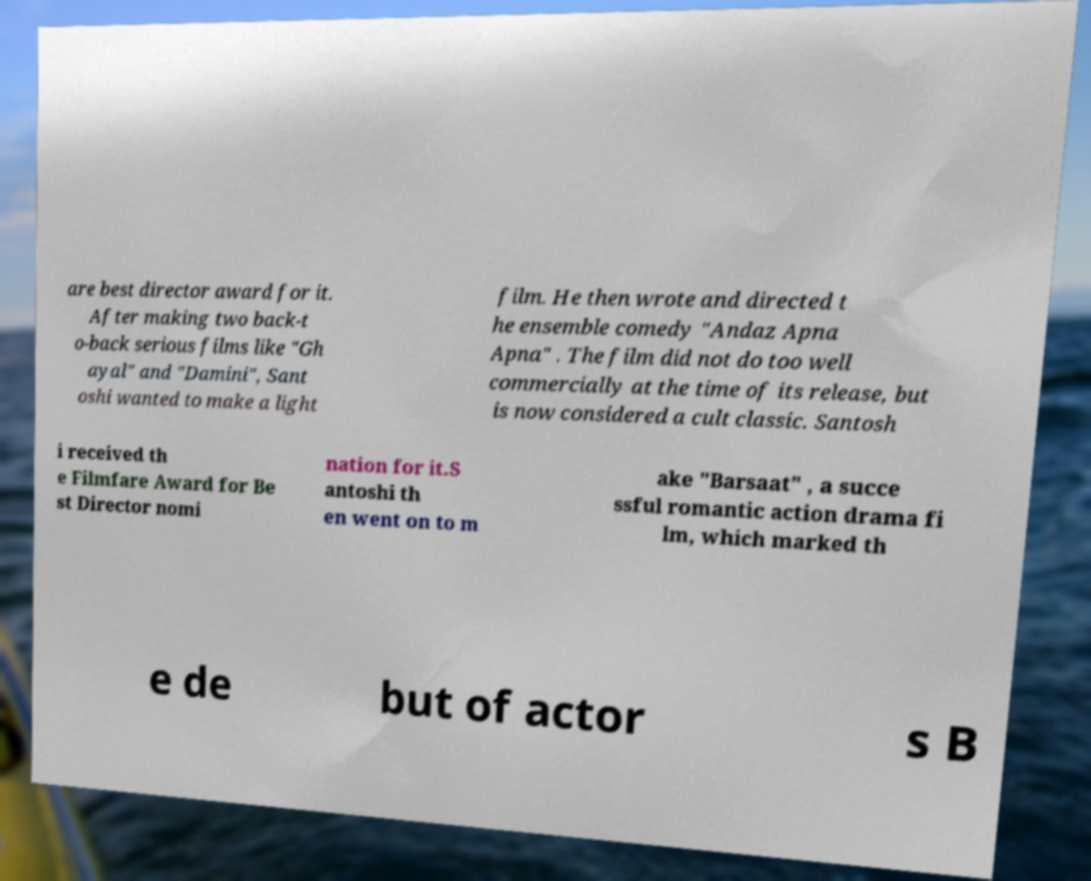What messages or text are displayed in this image? I need them in a readable, typed format. are best director award for it. After making two back-t o-back serious films like "Gh ayal" and "Damini", Sant oshi wanted to make a light film. He then wrote and directed t he ensemble comedy "Andaz Apna Apna" . The film did not do too well commercially at the time of its release, but is now considered a cult classic. Santosh i received th e Filmfare Award for Be st Director nomi nation for it.S antoshi th en went on to m ake "Barsaat" , a succe ssful romantic action drama fi lm, which marked th e de but of actor s B 